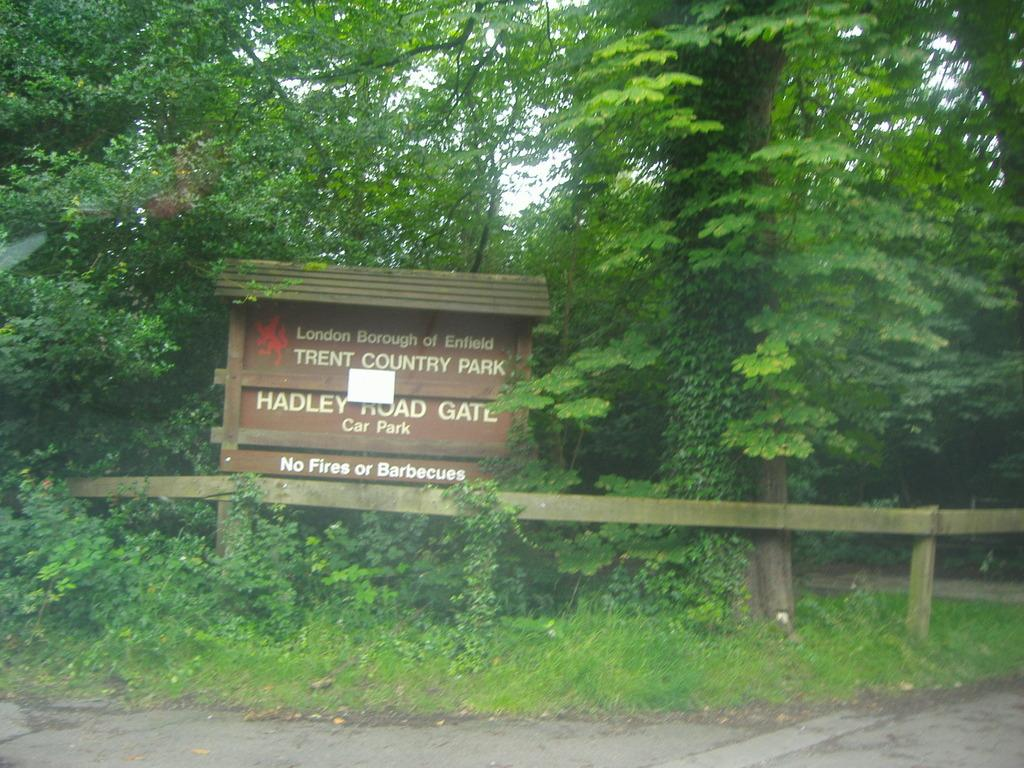What is the main object in the center of the image? There is a board in the center of the image. What is located at the bottom of the image? There is a road at the bottom of the image. What type of barrier can be seen in the image? There is a fence in the image. What can be seen in the distance in the image? There are trees and the sky visible in the background of the image. What type of lunch is being prepared on the board in the image? There is no lunch or any indication of food preparation in the image; it only features a board, a road, a fence, trees, and the sky. 